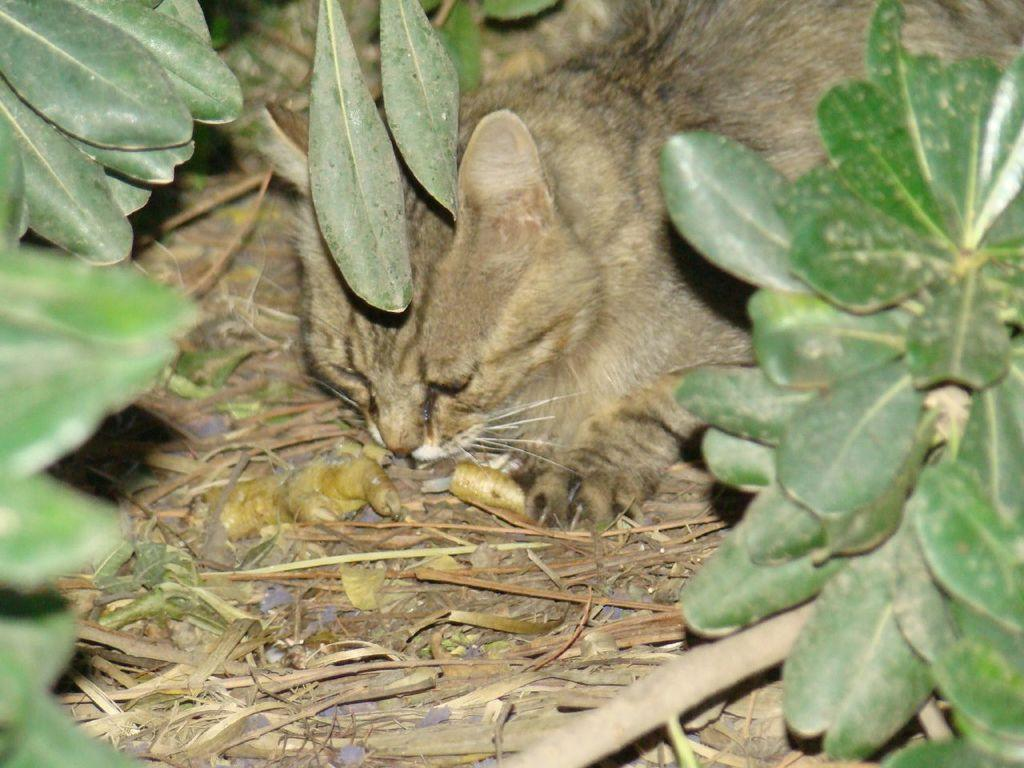What animal is present in the image? There is a cat in the image. Where is the cat located? The cat is on the ground. What can be seen in the background of the image? There is a group of leaves and dried grass in the background of the image. How many times does the cat sneeze in the image? The cat does not sneeze in the image; there is no indication of any sneezing. 